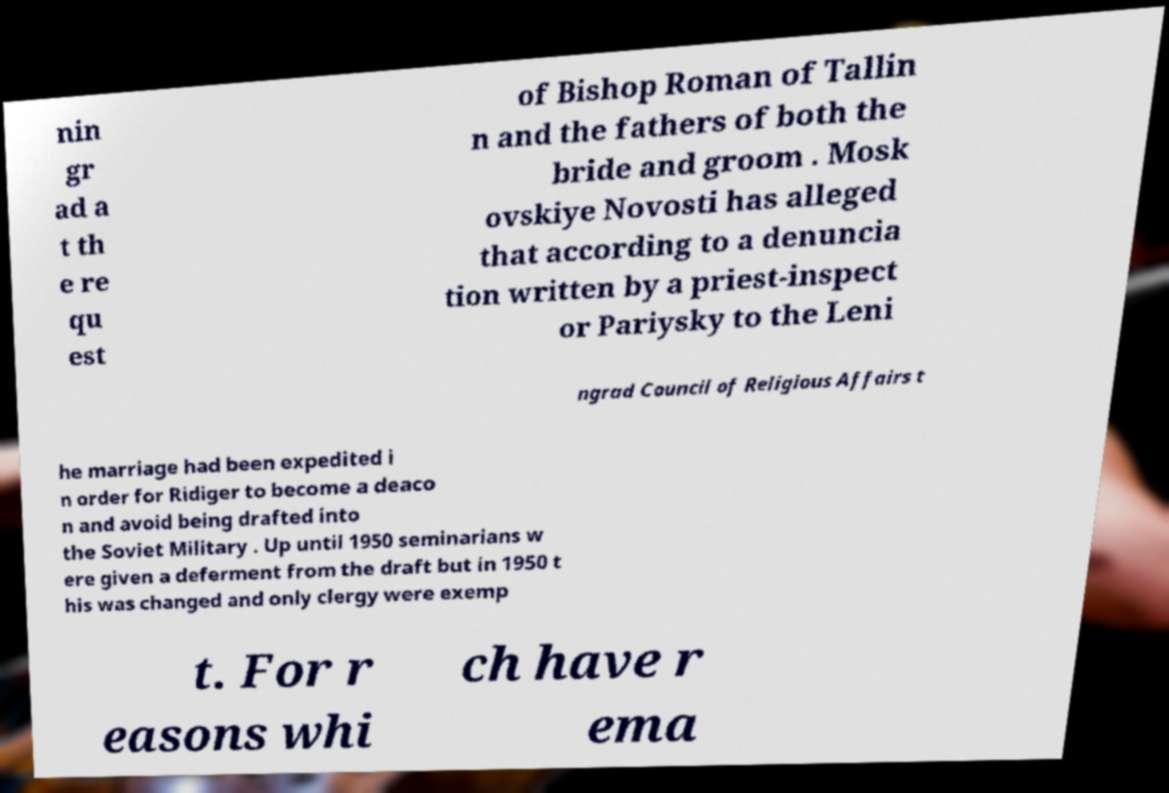Could you extract and type out the text from this image? nin gr ad a t th e re qu est of Bishop Roman of Tallin n and the fathers of both the bride and groom . Mosk ovskiye Novosti has alleged that according to a denuncia tion written by a priest-inspect or Pariysky to the Leni ngrad Council of Religious Affairs t he marriage had been expedited i n order for Ridiger to become a deaco n and avoid being drafted into the Soviet Military . Up until 1950 seminarians w ere given a deferment from the draft but in 1950 t his was changed and only clergy were exemp t. For r easons whi ch have r ema 